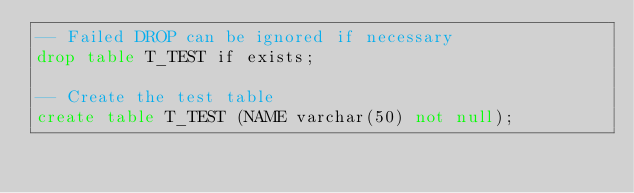Convert code to text. <code><loc_0><loc_0><loc_500><loc_500><_SQL_>-- Failed DROP can be ignored if necessary 
drop table T_TEST if exists;

-- Create the test table
create table T_TEST (NAME varchar(50) not null);</code> 